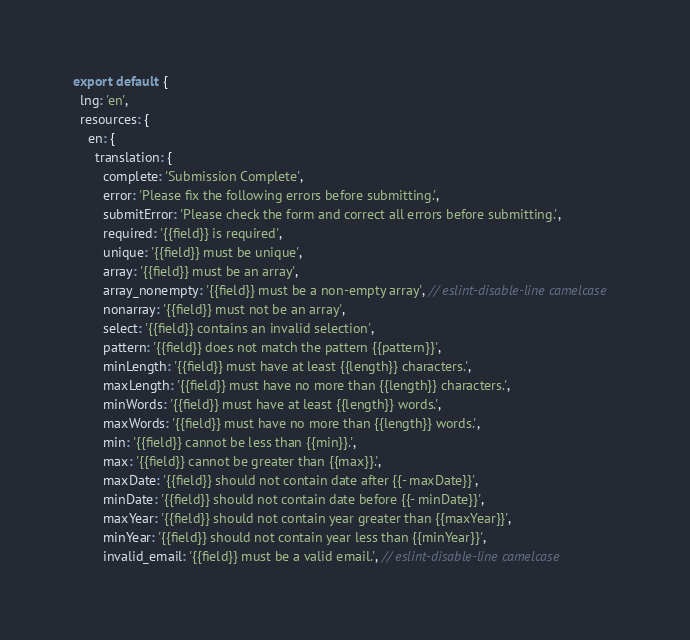Convert code to text. <code><loc_0><loc_0><loc_500><loc_500><_JavaScript_>export default {
  lng: 'en',
  resources: {
    en: {
      translation: {
        complete: 'Submission Complete',
        error: 'Please fix the following errors before submitting.',
        submitError: 'Please check the form and correct all errors before submitting.',
        required: '{{field}} is required',
        unique: '{{field}} must be unique',
        array: '{{field}} must be an array',
        array_nonempty: '{{field}} must be a non-empty array', // eslint-disable-line camelcase
        nonarray: '{{field}} must not be an array',
        select: '{{field}} contains an invalid selection',
        pattern: '{{field}} does not match the pattern {{pattern}}',
        minLength: '{{field}} must have at least {{length}} characters.',
        maxLength: '{{field}} must have no more than {{length}} characters.',
        minWords: '{{field}} must have at least {{length}} words.',
        maxWords: '{{field}} must have no more than {{length}} words.',
        min: '{{field}} cannot be less than {{min}}.',
        max: '{{field}} cannot be greater than {{max}}.',
        maxDate: '{{field}} should not contain date after {{- maxDate}}',
        minDate: '{{field}} should not contain date before {{- minDate}}',
        maxYear: '{{field}} should not contain year greater than {{maxYear}}',
        minYear: '{{field}} should not contain year less than {{minYear}}',
        invalid_email: '{{field}} must be a valid email.', // eslint-disable-line camelcase</code> 